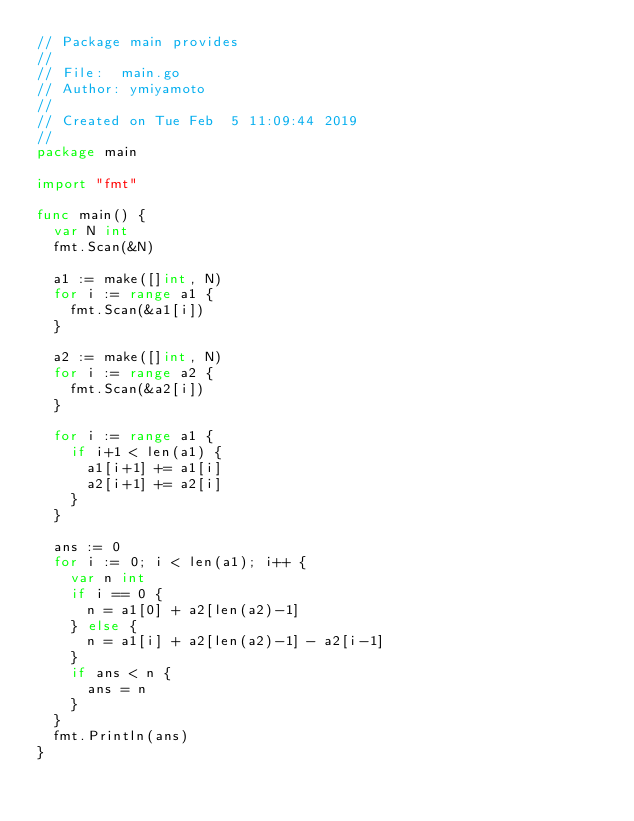Convert code to text. <code><loc_0><loc_0><loc_500><loc_500><_Go_>// Package main provides
//
// File:  main.go
// Author: ymiyamoto
//
// Created on Tue Feb  5 11:09:44 2019
//
package main

import "fmt"

func main() {
	var N int
	fmt.Scan(&N)

	a1 := make([]int, N)
	for i := range a1 {
		fmt.Scan(&a1[i])
	}

	a2 := make([]int, N)
	for i := range a2 {
		fmt.Scan(&a2[i])
	}

	for i := range a1 {
		if i+1 < len(a1) {
			a1[i+1] += a1[i]
			a2[i+1] += a2[i]
		}
	}

	ans := 0
	for i := 0; i < len(a1); i++ {
		var n int
		if i == 0 {
			n = a1[0] + a2[len(a2)-1]
		} else {
			n = a1[i] + a2[len(a2)-1] - a2[i-1]
		}
		if ans < n {
			ans = n
		}
	}
	fmt.Println(ans)
}
</code> 